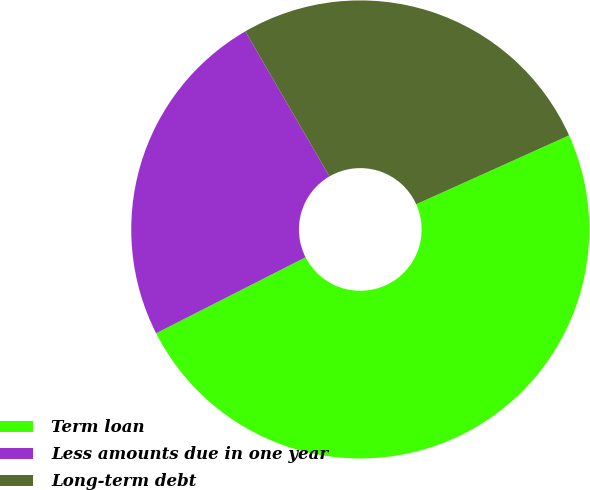<chart> <loc_0><loc_0><loc_500><loc_500><pie_chart><fcel>Term loan<fcel>Less amounts due in one year<fcel>Long-term debt<nl><fcel>49.25%<fcel>24.12%<fcel>26.63%<nl></chart> 